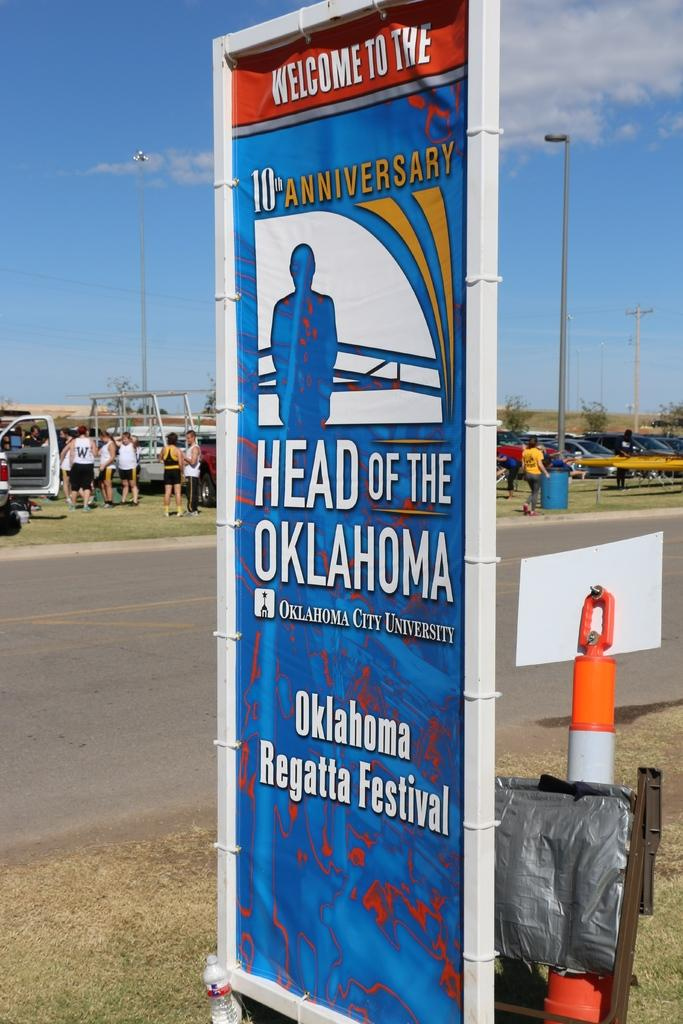What is hanging in the image? There is a banner in the image. What is covering something in the image? There is a cover in the image. What is supporting the banner in the image? There is a pole in the image. What can be seen for hydration purposes in the image? There is a water bottle in the image. What are the tall structures with lights in the image? There are light poles in the image. Who is present in the image? There are people standing in the image. What type of transportation is parked in the image? There are vehicles parked in the image. What type of vegetation is visible in the image? There are trees in the image. What is the color and condition of the sky in the image? The sky is blue with clouds in the background. What news is being reported on the banner in the image? There is no news being reported on the banner in the image. The banner in the image is not displaying any news. --- Facts: 1. There is a person in the image. 2. The person is wearing a hat. 3. The person is holding a book. 4. The person is sitting on a chair. 5. The chair is made of wood. 6. The background of the image is a library. Absurd Topics: dinosaur, ocean, spaceship Conversation: Who is present in the image? There is a person in the image. What is the person wearing in the image? The person is wearing a hat in the image. What is the person holding in the image? The person is holding a book in the image. What is the person doing in the image? The person is sitting on a chair in the image. What is the chair made of in the image? The chair is made of wood in the image. What is the background of the image? The background of the image is a library. Reasoning: Let's think step by step in order to produce the conversation. We start by identifying the main subject in the image, which is the person. Then, we describe specific features of the person, such as the hat and the book they are holding. Next, we observe the actions of the person, noting that they are sitting on a chair. We then describe the chair's material, which is wood. Finally, we describe the background of the image, which is a library. Absurd Question/Answer: Can you see a dinosaur in the image? No, there is no dinosaur present in the image. --- Facts: 1. There is a dog in the image. 2. The dog is lying down on the grass. 3. The grass is green. 4. There is a fence in the background of the image. 5. The sky is visible in the background of the image 